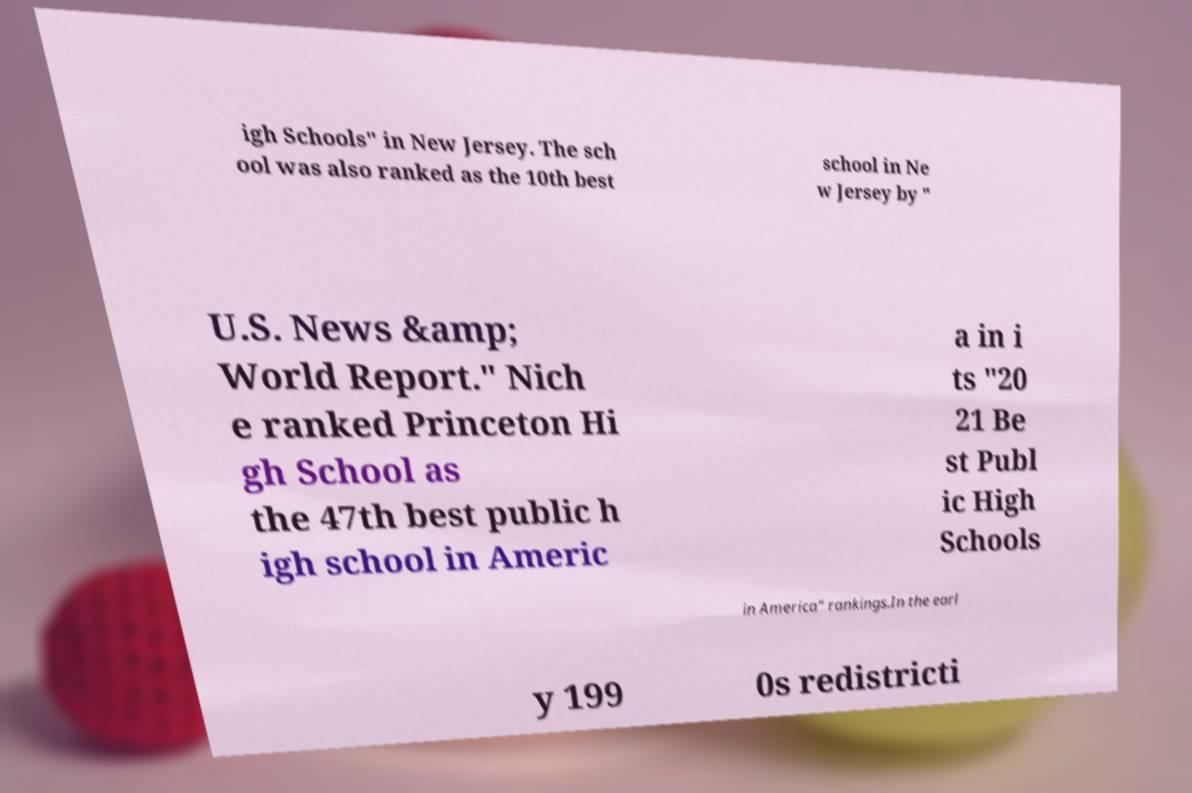For documentation purposes, I need the text within this image transcribed. Could you provide that? igh Schools" in New Jersey. The sch ool was also ranked as the 10th best school in Ne w Jersey by " U.S. News &amp; World Report." Nich e ranked Princeton Hi gh School as the 47th best public h igh school in Americ a in i ts "20 21 Be st Publ ic High Schools in America" rankings.In the earl y 199 0s redistricti 